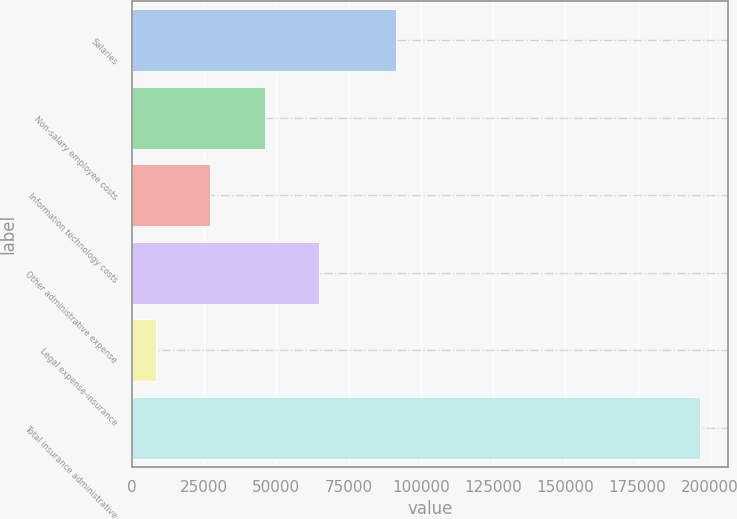Convert chart. <chart><loc_0><loc_0><loc_500><loc_500><bar_chart><fcel>Salaries<fcel>Non-salary employee costs<fcel>Information technology costs<fcel>Other administrative expense<fcel>Legal expense-insurance<fcel>Total insurance administrative<nl><fcel>91415<fcel>45960.4<fcel>27130.7<fcel>64790.1<fcel>8301<fcel>196598<nl></chart> 